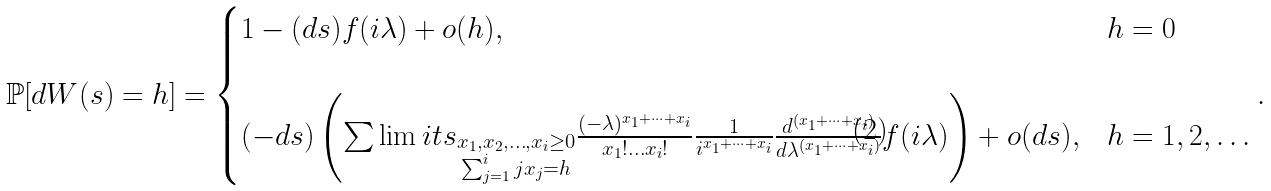<formula> <loc_0><loc_0><loc_500><loc_500>\mathbb { P } [ d W ( s ) = h ] = \begin{cases} 1 - ( d s ) f ( i \lambda ) + o ( h ) , & h = 0 \\ & \\ ( - d s ) \left ( \sum \lim i t s _ { \substack { x _ { 1 } , x _ { 2 } , \dots , x _ { i } \geq 0 \\ \sum _ { j = 1 } ^ { i } j x _ { j } = h } } \frac { ( - \lambda ) ^ { x _ { 1 } + \dots + x _ { i } } } { x _ { 1 } ! \dots x _ { i } ! } \frac { 1 } { i ^ { x _ { 1 } + \dots + x _ { i } } } \frac { d ^ { ( x _ { 1 } + \dots + x _ { i } ) } } { d \lambda ^ { ( x _ { 1 } + \dots + x _ { i } ) } } f ( i \lambda ) \right ) + o ( d s ) , & h = 1 , 2 , \dots \end{cases} .</formula> 